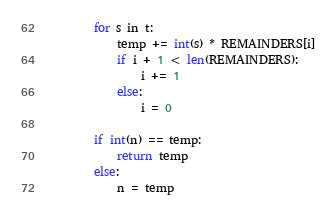<code> <loc_0><loc_0><loc_500><loc_500><_Python_>        for s in t:
            temp += int(s) * REMAINDERS[i]
            if i + 1 < len(REMAINDERS):
                i += 1
            else:
                i = 0

        if int(n) == temp:
            return temp
        else:
            n = temp

</code> 